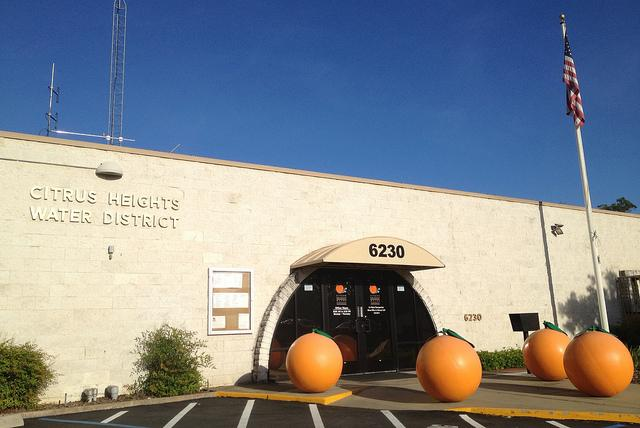What time in the morning does this building open to the public?

Choices:
A) nine
B) ten
C) 11
D) eight eight 